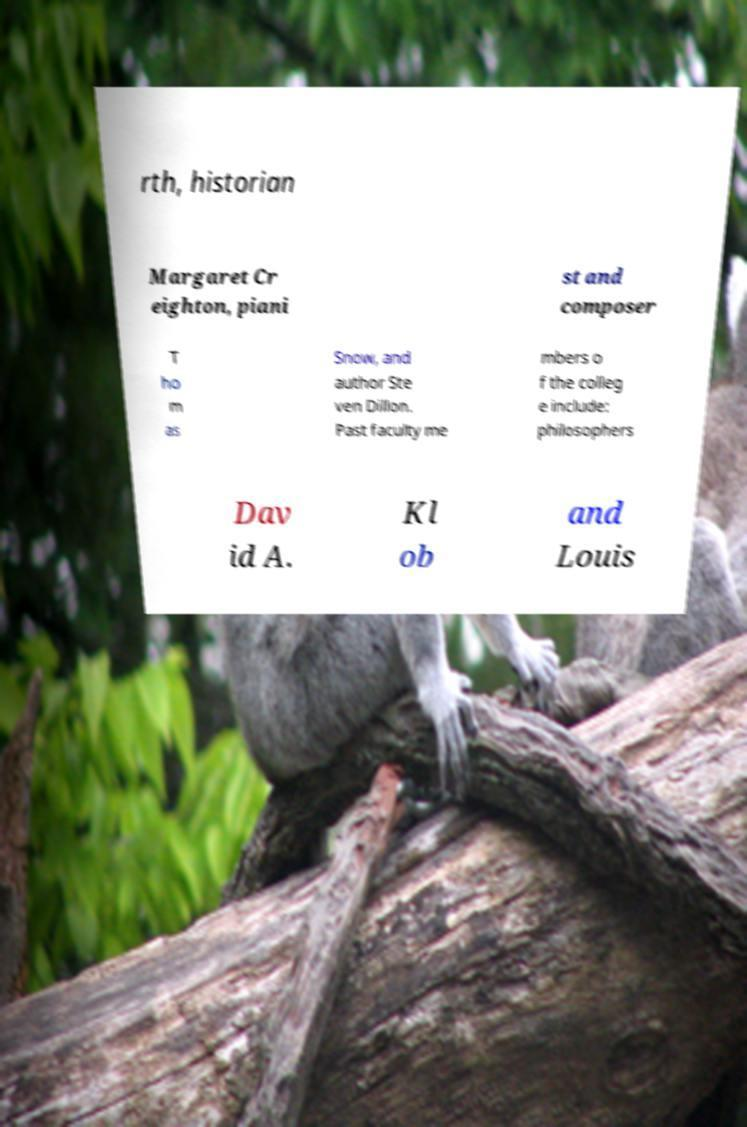For documentation purposes, I need the text within this image transcribed. Could you provide that? rth, historian Margaret Cr eighton, piani st and composer T ho m as Snow, and author Ste ven Dillon. Past faculty me mbers o f the colleg e include: philosophers Dav id A. Kl ob and Louis 